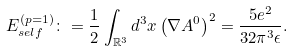<formula> <loc_0><loc_0><loc_500><loc_500>E _ { s e l f } ^ { ( p = 1 ) } \colon = \frac { 1 } { 2 } \int _ { \mathbb { R } ^ { 3 } } d ^ { 3 } x \left ( \nabla A ^ { 0 } \right ) ^ { 2 } = \frac { 5 e ^ { 2 } } { 3 2 \pi ^ { 3 } \epsilon } .</formula> 